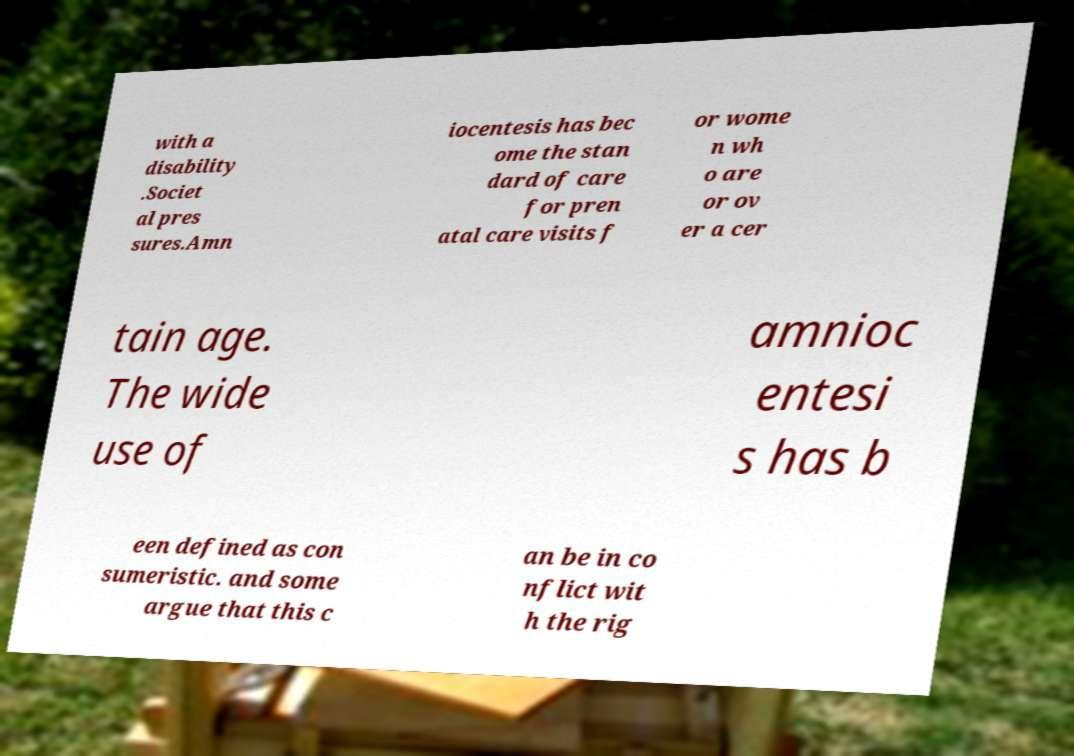Can you read and provide the text displayed in the image?This photo seems to have some interesting text. Can you extract and type it out for me? with a disability .Societ al pres sures.Amn iocentesis has bec ome the stan dard of care for pren atal care visits f or wome n wh o are or ov er a cer tain age. The wide use of amnioc entesi s has b een defined as con sumeristic. and some argue that this c an be in co nflict wit h the rig 